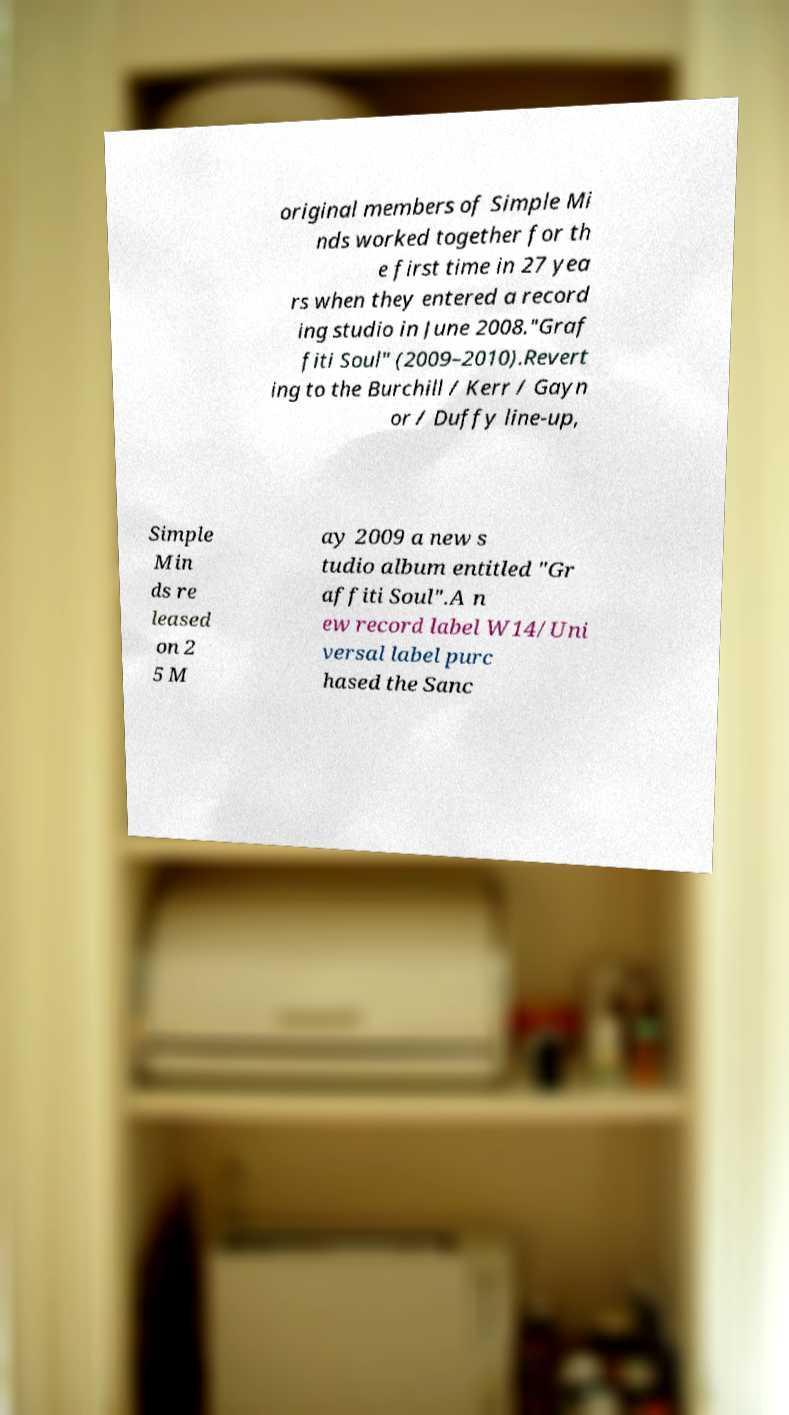Could you extract and type out the text from this image? original members of Simple Mi nds worked together for th e first time in 27 yea rs when they entered a record ing studio in June 2008."Graf fiti Soul" (2009–2010).Revert ing to the Burchill / Kerr / Gayn or / Duffy line-up, Simple Min ds re leased on 2 5 M ay 2009 a new s tudio album entitled "Gr affiti Soul".A n ew record label W14/Uni versal label purc hased the Sanc 